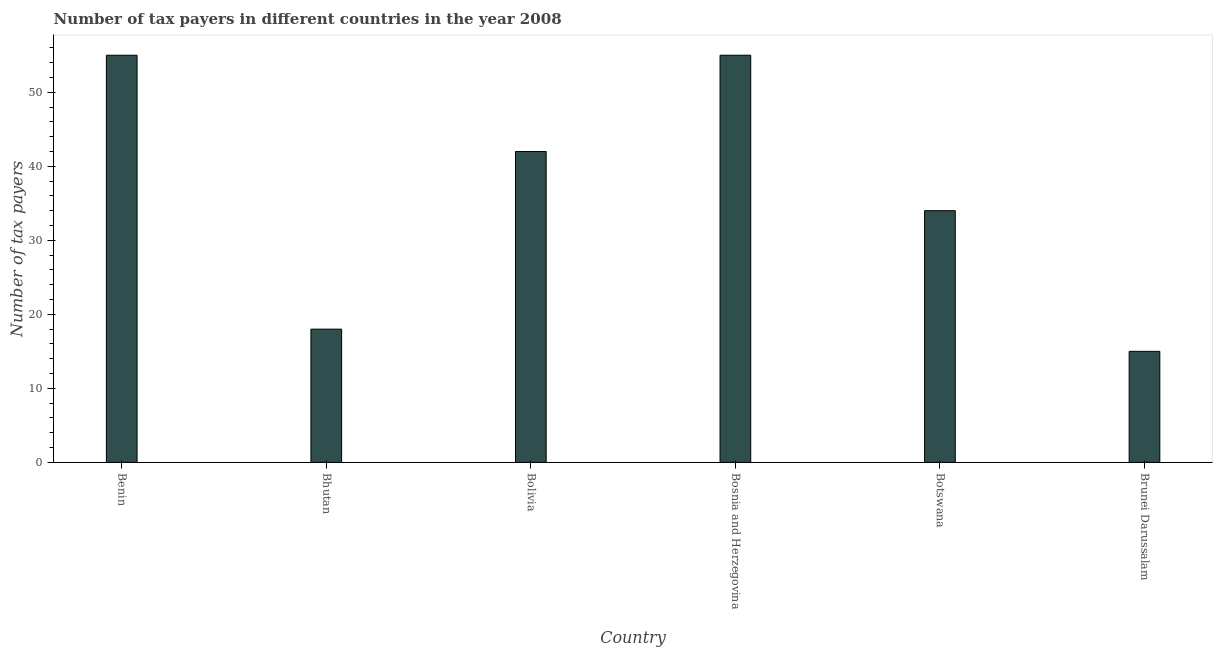Does the graph contain any zero values?
Make the answer very short. No. Does the graph contain grids?
Offer a very short reply. No. What is the title of the graph?
Provide a succinct answer. Number of tax payers in different countries in the year 2008. What is the label or title of the Y-axis?
Keep it short and to the point. Number of tax payers. In which country was the number of tax payers maximum?
Your answer should be compact. Benin. In which country was the number of tax payers minimum?
Keep it short and to the point. Brunei Darussalam. What is the sum of the number of tax payers?
Give a very brief answer. 219. What is the difference between the number of tax payers in Botswana and Brunei Darussalam?
Offer a very short reply. 19. What is the average number of tax payers per country?
Your response must be concise. 36.5. What is the ratio of the number of tax payers in Bhutan to that in Bosnia and Herzegovina?
Your response must be concise. 0.33. Is the number of tax payers in Bolivia less than that in Brunei Darussalam?
Give a very brief answer. No. What is the difference between the highest and the lowest number of tax payers?
Give a very brief answer. 40. In how many countries, is the number of tax payers greater than the average number of tax payers taken over all countries?
Provide a short and direct response. 3. How many countries are there in the graph?
Provide a succinct answer. 6. What is the difference between two consecutive major ticks on the Y-axis?
Ensure brevity in your answer.  10. Are the values on the major ticks of Y-axis written in scientific E-notation?
Offer a very short reply. No. What is the Number of tax payers in Bosnia and Herzegovina?
Give a very brief answer. 55. What is the Number of tax payers in Brunei Darussalam?
Give a very brief answer. 15. What is the difference between the Number of tax payers in Benin and Bolivia?
Ensure brevity in your answer.  13. What is the difference between the Number of tax payers in Benin and Bosnia and Herzegovina?
Ensure brevity in your answer.  0. What is the difference between the Number of tax payers in Benin and Botswana?
Ensure brevity in your answer.  21. What is the difference between the Number of tax payers in Bhutan and Bolivia?
Make the answer very short. -24. What is the difference between the Number of tax payers in Bhutan and Bosnia and Herzegovina?
Your response must be concise. -37. What is the difference between the Number of tax payers in Bhutan and Botswana?
Your response must be concise. -16. What is the difference between the Number of tax payers in Bhutan and Brunei Darussalam?
Make the answer very short. 3. What is the difference between the Number of tax payers in Bolivia and Botswana?
Give a very brief answer. 8. What is the difference between the Number of tax payers in Bosnia and Herzegovina and Botswana?
Keep it short and to the point. 21. What is the ratio of the Number of tax payers in Benin to that in Bhutan?
Provide a succinct answer. 3.06. What is the ratio of the Number of tax payers in Benin to that in Bolivia?
Make the answer very short. 1.31. What is the ratio of the Number of tax payers in Benin to that in Bosnia and Herzegovina?
Ensure brevity in your answer.  1. What is the ratio of the Number of tax payers in Benin to that in Botswana?
Your response must be concise. 1.62. What is the ratio of the Number of tax payers in Benin to that in Brunei Darussalam?
Make the answer very short. 3.67. What is the ratio of the Number of tax payers in Bhutan to that in Bolivia?
Provide a short and direct response. 0.43. What is the ratio of the Number of tax payers in Bhutan to that in Bosnia and Herzegovina?
Your answer should be very brief. 0.33. What is the ratio of the Number of tax payers in Bhutan to that in Botswana?
Your answer should be very brief. 0.53. What is the ratio of the Number of tax payers in Bolivia to that in Bosnia and Herzegovina?
Make the answer very short. 0.76. What is the ratio of the Number of tax payers in Bolivia to that in Botswana?
Ensure brevity in your answer.  1.24. What is the ratio of the Number of tax payers in Bolivia to that in Brunei Darussalam?
Keep it short and to the point. 2.8. What is the ratio of the Number of tax payers in Bosnia and Herzegovina to that in Botswana?
Provide a succinct answer. 1.62. What is the ratio of the Number of tax payers in Bosnia and Herzegovina to that in Brunei Darussalam?
Your answer should be very brief. 3.67. What is the ratio of the Number of tax payers in Botswana to that in Brunei Darussalam?
Your answer should be compact. 2.27. 